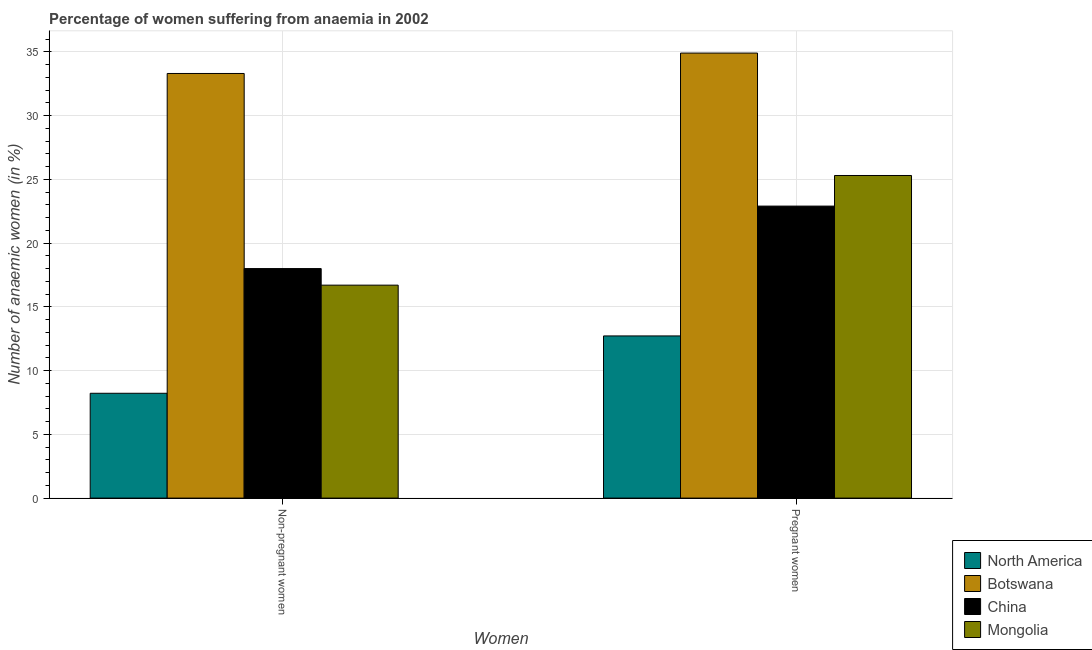How many groups of bars are there?
Your answer should be very brief. 2. Are the number of bars on each tick of the X-axis equal?
Your response must be concise. Yes. How many bars are there on the 2nd tick from the left?
Your response must be concise. 4. What is the label of the 1st group of bars from the left?
Ensure brevity in your answer.  Non-pregnant women. What is the percentage of non-pregnant anaemic women in Mongolia?
Offer a terse response. 16.7. Across all countries, what is the maximum percentage of pregnant anaemic women?
Provide a short and direct response. 34.9. Across all countries, what is the minimum percentage of non-pregnant anaemic women?
Ensure brevity in your answer.  8.22. In which country was the percentage of pregnant anaemic women maximum?
Your answer should be very brief. Botswana. In which country was the percentage of non-pregnant anaemic women minimum?
Keep it short and to the point. North America. What is the total percentage of pregnant anaemic women in the graph?
Your answer should be compact. 95.82. What is the difference between the percentage of pregnant anaemic women in Mongolia and the percentage of non-pregnant anaemic women in Botswana?
Offer a terse response. -8. What is the average percentage of non-pregnant anaemic women per country?
Offer a terse response. 19.06. What is the difference between the percentage of pregnant anaemic women and percentage of non-pregnant anaemic women in Mongolia?
Ensure brevity in your answer.  8.6. In how many countries, is the percentage of pregnant anaemic women greater than 8 %?
Give a very brief answer. 4. What is the ratio of the percentage of non-pregnant anaemic women in Botswana to that in China?
Make the answer very short. 1.85. In how many countries, is the percentage of pregnant anaemic women greater than the average percentage of pregnant anaemic women taken over all countries?
Give a very brief answer. 2. What does the 2nd bar from the left in Non-pregnant women represents?
Ensure brevity in your answer.  Botswana. What is the difference between two consecutive major ticks on the Y-axis?
Give a very brief answer. 5. Does the graph contain any zero values?
Make the answer very short. No. What is the title of the graph?
Offer a terse response. Percentage of women suffering from anaemia in 2002. What is the label or title of the X-axis?
Your answer should be very brief. Women. What is the label or title of the Y-axis?
Your response must be concise. Number of anaemic women (in %). What is the Number of anaemic women (in %) of North America in Non-pregnant women?
Keep it short and to the point. 8.22. What is the Number of anaemic women (in %) in Botswana in Non-pregnant women?
Ensure brevity in your answer.  33.3. What is the Number of anaemic women (in %) in China in Non-pregnant women?
Make the answer very short. 18. What is the Number of anaemic women (in %) of North America in Pregnant women?
Your response must be concise. 12.72. What is the Number of anaemic women (in %) in Botswana in Pregnant women?
Make the answer very short. 34.9. What is the Number of anaemic women (in %) of China in Pregnant women?
Provide a short and direct response. 22.9. What is the Number of anaemic women (in %) of Mongolia in Pregnant women?
Make the answer very short. 25.3. Across all Women, what is the maximum Number of anaemic women (in %) of North America?
Keep it short and to the point. 12.72. Across all Women, what is the maximum Number of anaemic women (in %) of Botswana?
Keep it short and to the point. 34.9. Across all Women, what is the maximum Number of anaemic women (in %) of China?
Your answer should be compact. 22.9. Across all Women, what is the maximum Number of anaemic women (in %) of Mongolia?
Make the answer very short. 25.3. Across all Women, what is the minimum Number of anaemic women (in %) in North America?
Ensure brevity in your answer.  8.22. Across all Women, what is the minimum Number of anaemic women (in %) in Botswana?
Offer a terse response. 33.3. Across all Women, what is the minimum Number of anaemic women (in %) of Mongolia?
Ensure brevity in your answer.  16.7. What is the total Number of anaemic women (in %) of North America in the graph?
Make the answer very short. 20.94. What is the total Number of anaemic women (in %) of Botswana in the graph?
Keep it short and to the point. 68.2. What is the total Number of anaemic women (in %) of China in the graph?
Your answer should be compact. 40.9. What is the difference between the Number of anaemic women (in %) of North America in Non-pregnant women and that in Pregnant women?
Ensure brevity in your answer.  -4.5. What is the difference between the Number of anaemic women (in %) in China in Non-pregnant women and that in Pregnant women?
Offer a very short reply. -4.9. What is the difference between the Number of anaemic women (in %) of Mongolia in Non-pregnant women and that in Pregnant women?
Give a very brief answer. -8.6. What is the difference between the Number of anaemic women (in %) in North America in Non-pregnant women and the Number of anaemic women (in %) in Botswana in Pregnant women?
Offer a terse response. -26.68. What is the difference between the Number of anaemic women (in %) in North America in Non-pregnant women and the Number of anaemic women (in %) in China in Pregnant women?
Your answer should be compact. -14.68. What is the difference between the Number of anaemic women (in %) of North America in Non-pregnant women and the Number of anaemic women (in %) of Mongolia in Pregnant women?
Provide a short and direct response. -17.08. What is the difference between the Number of anaemic women (in %) in Botswana in Non-pregnant women and the Number of anaemic women (in %) in China in Pregnant women?
Keep it short and to the point. 10.4. What is the average Number of anaemic women (in %) in North America per Women?
Your answer should be compact. 10.47. What is the average Number of anaemic women (in %) in Botswana per Women?
Ensure brevity in your answer.  34.1. What is the average Number of anaemic women (in %) in China per Women?
Your answer should be very brief. 20.45. What is the difference between the Number of anaemic women (in %) of North America and Number of anaemic women (in %) of Botswana in Non-pregnant women?
Your answer should be very brief. -25.08. What is the difference between the Number of anaemic women (in %) of North America and Number of anaemic women (in %) of China in Non-pregnant women?
Provide a short and direct response. -9.78. What is the difference between the Number of anaemic women (in %) in North America and Number of anaemic women (in %) in Mongolia in Non-pregnant women?
Your answer should be very brief. -8.48. What is the difference between the Number of anaemic women (in %) of Botswana and Number of anaemic women (in %) of China in Non-pregnant women?
Your answer should be compact. 15.3. What is the difference between the Number of anaemic women (in %) of North America and Number of anaemic women (in %) of Botswana in Pregnant women?
Offer a terse response. -22.18. What is the difference between the Number of anaemic women (in %) in North America and Number of anaemic women (in %) in China in Pregnant women?
Give a very brief answer. -10.18. What is the difference between the Number of anaemic women (in %) in North America and Number of anaemic women (in %) in Mongolia in Pregnant women?
Provide a short and direct response. -12.58. What is the ratio of the Number of anaemic women (in %) in North America in Non-pregnant women to that in Pregnant women?
Make the answer very short. 0.65. What is the ratio of the Number of anaemic women (in %) of Botswana in Non-pregnant women to that in Pregnant women?
Give a very brief answer. 0.95. What is the ratio of the Number of anaemic women (in %) of China in Non-pregnant women to that in Pregnant women?
Your answer should be compact. 0.79. What is the ratio of the Number of anaemic women (in %) of Mongolia in Non-pregnant women to that in Pregnant women?
Make the answer very short. 0.66. What is the difference between the highest and the second highest Number of anaemic women (in %) of North America?
Ensure brevity in your answer.  4.5. What is the difference between the highest and the second highest Number of anaemic women (in %) of Mongolia?
Offer a very short reply. 8.6. What is the difference between the highest and the lowest Number of anaemic women (in %) in North America?
Provide a succinct answer. 4.5. What is the difference between the highest and the lowest Number of anaemic women (in %) in Botswana?
Provide a succinct answer. 1.6. What is the difference between the highest and the lowest Number of anaemic women (in %) in Mongolia?
Give a very brief answer. 8.6. 